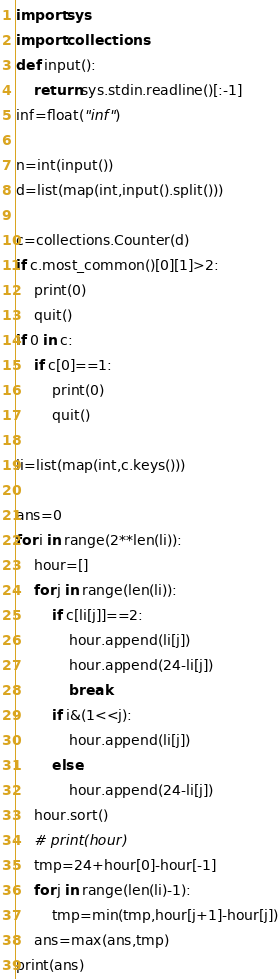<code> <loc_0><loc_0><loc_500><loc_500><_Python_>import sys
import collections
def input():
    return sys.stdin.readline()[:-1]
inf=float("inf")

n=int(input())
d=list(map(int,input().split()))

c=collections.Counter(d)
if c.most_common()[0][1]>2:
    print(0)
    quit()
if 0 in c:
    if c[0]==1:
        print(0)
        quit()

li=list(map(int,c.keys()))

ans=0
for i in range(2**len(li)):
    hour=[]
    for j in range(len(li)):
        if c[li[j]]==2:
            hour.append(li[j])
            hour.append(24-li[j])
            break
        if i&(1<<j):
            hour.append(li[j])
        else:
            hour.append(24-li[j])
    hour.sort()
    # print(hour)
    tmp=24+hour[0]-hour[-1]
    for j in range(len(li)-1):
        tmp=min(tmp,hour[j+1]-hour[j])
    ans=max(ans,tmp)
print(ans)</code> 